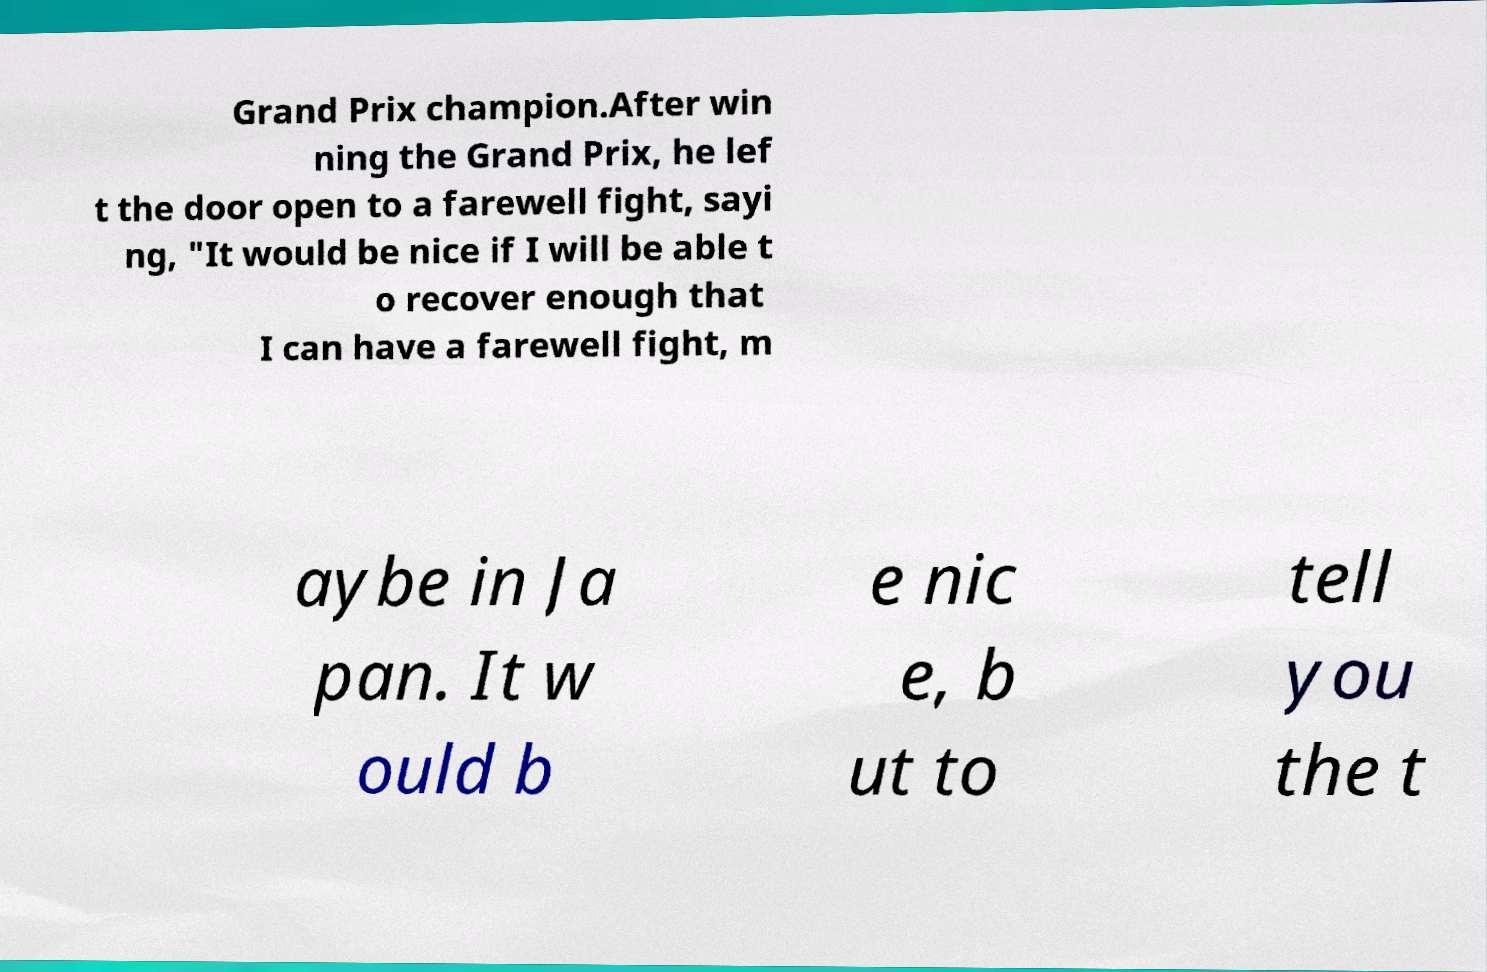Can you accurately transcribe the text from the provided image for me? Grand Prix champion.After win ning the Grand Prix, he lef t the door open to a farewell fight, sayi ng, "It would be nice if I will be able t o recover enough that I can have a farewell fight, m aybe in Ja pan. It w ould b e nic e, b ut to tell you the t 